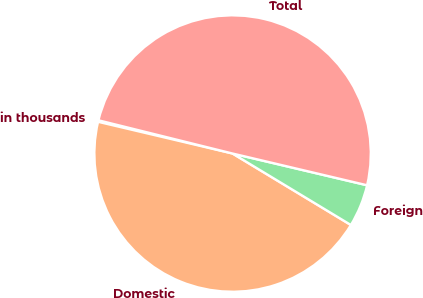<chart> <loc_0><loc_0><loc_500><loc_500><pie_chart><fcel>in thousands<fcel>Domestic<fcel>Foreign<fcel>Total<nl><fcel>0.18%<fcel>45.04%<fcel>4.96%<fcel>49.82%<nl></chart> 